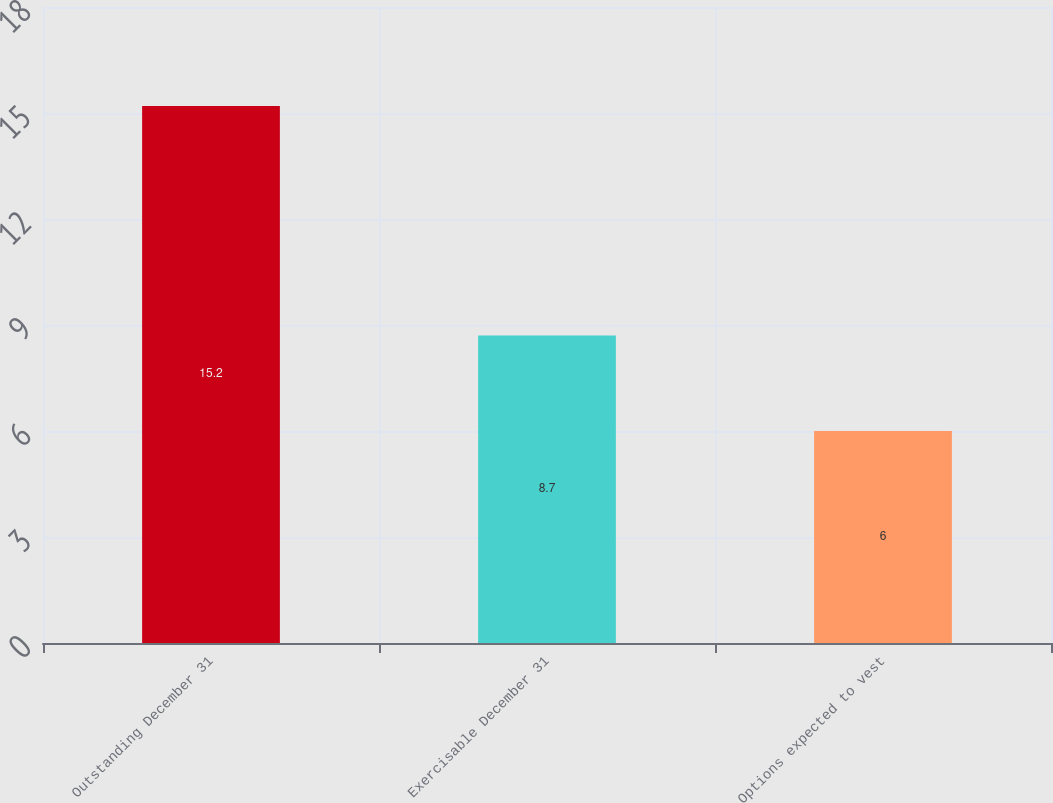Convert chart to OTSL. <chart><loc_0><loc_0><loc_500><loc_500><bar_chart><fcel>Outstanding December 31<fcel>Exercisable December 31<fcel>Options expected to vest<nl><fcel>15.2<fcel>8.7<fcel>6<nl></chart> 